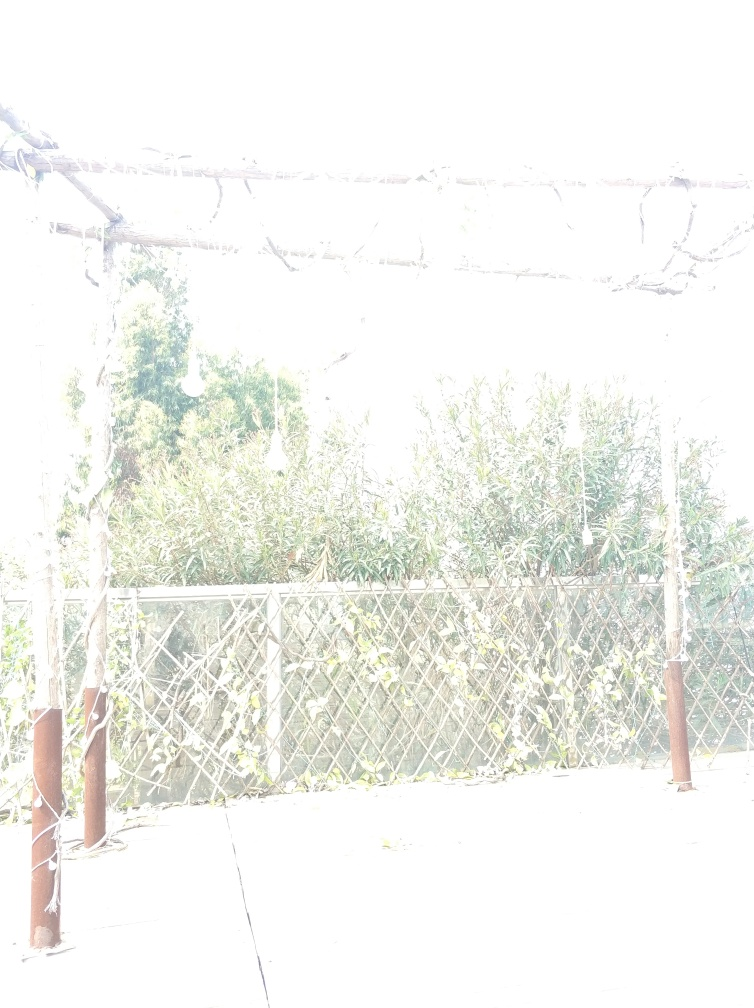What could have caused the overexposure in this image? Overexposure can happen for a few reasons: the camera's exposure settings like ISO, shutter speed, and aperture may have been set too high for the amount of light present. Alternatively, it could be due to the photographer's intention to create a certain effect or an accidental misconfiguration of the camera's automatic settings. 